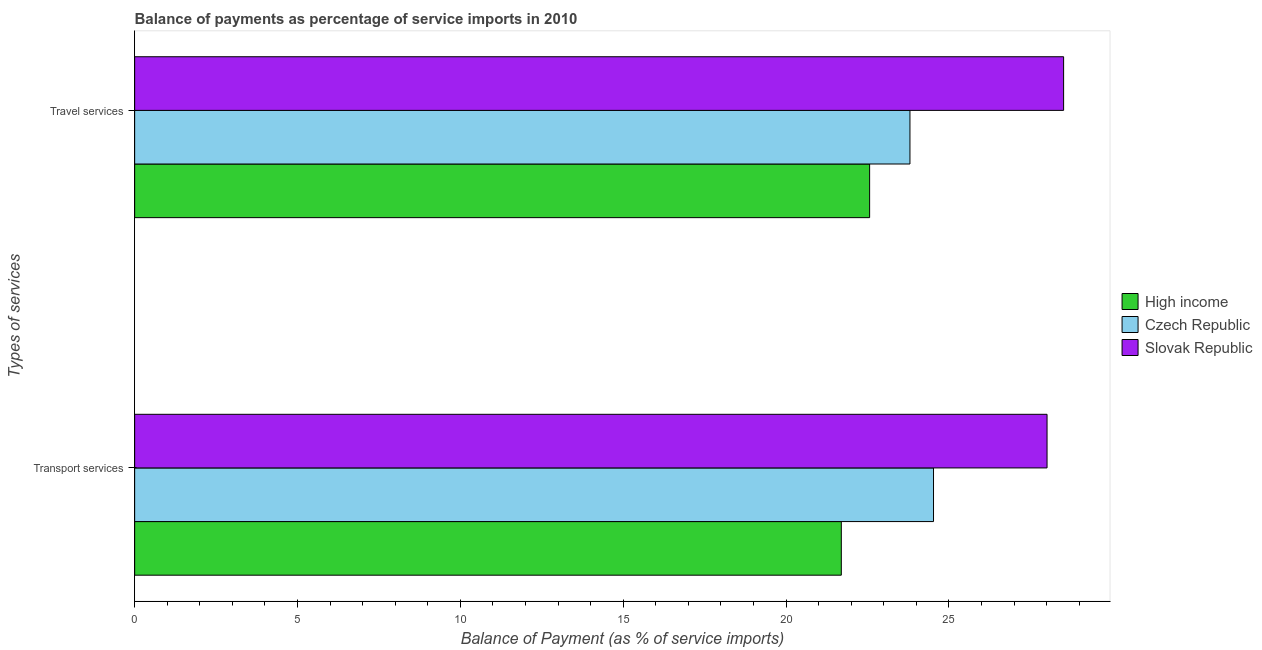Are the number of bars per tick equal to the number of legend labels?
Keep it short and to the point. Yes. Are the number of bars on each tick of the Y-axis equal?
Offer a terse response. Yes. How many bars are there on the 2nd tick from the top?
Give a very brief answer. 3. What is the label of the 2nd group of bars from the top?
Provide a short and direct response. Transport services. What is the balance of payments of travel services in Czech Republic?
Give a very brief answer. 23.8. Across all countries, what is the maximum balance of payments of travel services?
Provide a succinct answer. 28.52. Across all countries, what is the minimum balance of payments of transport services?
Provide a short and direct response. 21.7. In which country was the balance of payments of transport services maximum?
Your response must be concise. Slovak Republic. What is the total balance of payments of transport services in the graph?
Offer a very short reply. 74.24. What is the difference between the balance of payments of transport services in Slovak Republic and that in Czech Republic?
Ensure brevity in your answer.  3.49. What is the difference between the balance of payments of transport services in High income and the balance of payments of travel services in Czech Republic?
Provide a succinct answer. -2.11. What is the average balance of payments of travel services per country?
Offer a very short reply. 24.96. What is the difference between the balance of payments of transport services and balance of payments of travel services in High income?
Provide a succinct answer. -0.87. In how many countries, is the balance of payments of travel services greater than 24 %?
Keep it short and to the point. 1. What is the ratio of the balance of payments of transport services in High income to that in Slovak Republic?
Your response must be concise. 0.77. Is the balance of payments of travel services in High income less than that in Czech Republic?
Keep it short and to the point. Yes. In how many countries, is the balance of payments of travel services greater than the average balance of payments of travel services taken over all countries?
Your answer should be very brief. 1. What does the 1st bar from the top in Transport services represents?
Your answer should be compact. Slovak Republic. What does the 3rd bar from the bottom in Transport services represents?
Provide a succinct answer. Slovak Republic. How many bars are there?
Give a very brief answer. 6. Are all the bars in the graph horizontal?
Provide a short and direct response. Yes. How many countries are there in the graph?
Your answer should be compact. 3. Where does the legend appear in the graph?
Provide a succinct answer. Center right. How many legend labels are there?
Give a very brief answer. 3. How are the legend labels stacked?
Offer a very short reply. Vertical. What is the title of the graph?
Ensure brevity in your answer.  Balance of payments as percentage of service imports in 2010. What is the label or title of the X-axis?
Make the answer very short. Balance of Payment (as % of service imports). What is the label or title of the Y-axis?
Make the answer very short. Types of services. What is the Balance of Payment (as % of service imports) in High income in Transport services?
Provide a succinct answer. 21.7. What is the Balance of Payment (as % of service imports) in Czech Republic in Transport services?
Ensure brevity in your answer.  24.53. What is the Balance of Payment (as % of service imports) in Slovak Republic in Transport services?
Keep it short and to the point. 28.01. What is the Balance of Payment (as % of service imports) in High income in Travel services?
Your answer should be compact. 22.57. What is the Balance of Payment (as % of service imports) of Czech Republic in Travel services?
Ensure brevity in your answer.  23.8. What is the Balance of Payment (as % of service imports) of Slovak Republic in Travel services?
Give a very brief answer. 28.52. Across all Types of services, what is the maximum Balance of Payment (as % of service imports) in High income?
Offer a very short reply. 22.57. Across all Types of services, what is the maximum Balance of Payment (as % of service imports) of Czech Republic?
Your answer should be very brief. 24.53. Across all Types of services, what is the maximum Balance of Payment (as % of service imports) of Slovak Republic?
Offer a terse response. 28.52. Across all Types of services, what is the minimum Balance of Payment (as % of service imports) of High income?
Offer a terse response. 21.7. Across all Types of services, what is the minimum Balance of Payment (as % of service imports) in Czech Republic?
Make the answer very short. 23.8. Across all Types of services, what is the minimum Balance of Payment (as % of service imports) in Slovak Republic?
Give a very brief answer. 28.01. What is the total Balance of Payment (as % of service imports) in High income in the graph?
Provide a succinct answer. 44.26. What is the total Balance of Payment (as % of service imports) in Czech Republic in the graph?
Your answer should be compact. 48.33. What is the total Balance of Payment (as % of service imports) in Slovak Republic in the graph?
Make the answer very short. 56.53. What is the difference between the Balance of Payment (as % of service imports) in High income in Transport services and that in Travel services?
Provide a succinct answer. -0.87. What is the difference between the Balance of Payment (as % of service imports) of Czech Republic in Transport services and that in Travel services?
Keep it short and to the point. 0.72. What is the difference between the Balance of Payment (as % of service imports) of Slovak Republic in Transport services and that in Travel services?
Provide a short and direct response. -0.51. What is the difference between the Balance of Payment (as % of service imports) in High income in Transport services and the Balance of Payment (as % of service imports) in Czech Republic in Travel services?
Ensure brevity in your answer.  -2.11. What is the difference between the Balance of Payment (as % of service imports) in High income in Transport services and the Balance of Payment (as % of service imports) in Slovak Republic in Travel services?
Make the answer very short. -6.83. What is the difference between the Balance of Payment (as % of service imports) in Czech Republic in Transport services and the Balance of Payment (as % of service imports) in Slovak Republic in Travel services?
Ensure brevity in your answer.  -3.99. What is the average Balance of Payment (as % of service imports) of High income per Types of services?
Provide a succinct answer. 22.13. What is the average Balance of Payment (as % of service imports) of Czech Republic per Types of services?
Ensure brevity in your answer.  24.17. What is the average Balance of Payment (as % of service imports) in Slovak Republic per Types of services?
Give a very brief answer. 28.27. What is the difference between the Balance of Payment (as % of service imports) in High income and Balance of Payment (as % of service imports) in Czech Republic in Transport services?
Provide a short and direct response. -2.83. What is the difference between the Balance of Payment (as % of service imports) of High income and Balance of Payment (as % of service imports) of Slovak Republic in Transport services?
Your answer should be compact. -6.32. What is the difference between the Balance of Payment (as % of service imports) of Czech Republic and Balance of Payment (as % of service imports) of Slovak Republic in Transport services?
Keep it short and to the point. -3.49. What is the difference between the Balance of Payment (as % of service imports) of High income and Balance of Payment (as % of service imports) of Czech Republic in Travel services?
Your answer should be compact. -1.24. What is the difference between the Balance of Payment (as % of service imports) in High income and Balance of Payment (as % of service imports) in Slovak Republic in Travel services?
Offer a terse response. -5.96. What is the difference between the Balance of Payment (as % of service imports) of Czech Republic and Balance of Payment (as % of service imports) of Slovak Republic in Travel services?
Your answer should be very brief. -4.72. What is the ratio of the Balance of Payment (as % of service imports) in High income in Transport services to that in Travel services?
Offer a terse response. 0.96. What is the ratio of the Balance of Payment (as % of service imports) in Czech Republic in Transport services to that in Travel services?
Provide a succinct answer. 1.03. What is the ratio of the Balance of Payment (as % of service imports) of Slovak Republic in Transport services to that in Travel services?
Offer a terse response. 0.98. What is the difference between the highest and the second highest Balance of Payment (as % of service imports) of High income?
Your answer should be compact. 0.87. What is the difference between the highest and the second highest Balance of Payment (as % of service imports) of Czech Republic?
Provide a short and direct response. 0.72. What is the difference between the highest and the second highest Balance of Payment (as % of service imports) in Slovak Republic?
Provide a short and direct response. 0.51. What is the difference between the highest and the lowest Balance of Payment (as % of service imports) of High income?
Provide a succinct answer. 0.87. What is the difference between the highest and the lowest Balance of Payment (as % of service imports) in Czech Republic?
Make the answer very short. 0.72. What is the difference between the highest and the lowest Balance of Payment (as % of service imports) in Slovak Republic?
Keep it short and to the point. 0.51. 